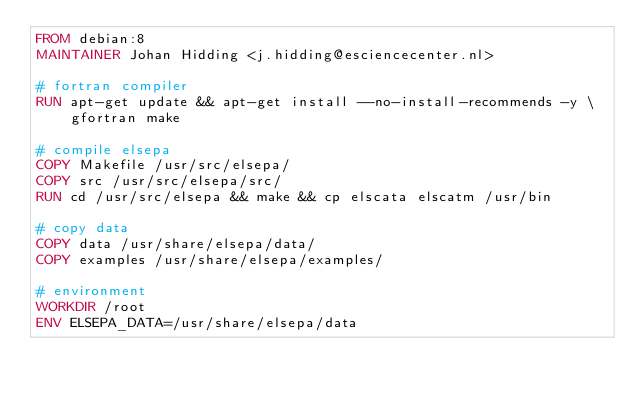Convert code to text. <code><loc_0><loc_0><loc_500><loc_500><_Dockerfile_>FROM debian:8
MAINTAINER Johan Hidding <j.hidding@esciencecenter.nl>

# fortran compiler
RUN apt-get update && apt-get install --no-install-recommends -y \
    gfortran make

# compile elsepa
COPY Makefile /usr/src/elsepa/
COPY src /usr/src/elsepa/src/
RUN cd /usr/src/elsepa && make && cp elscata elscatm /usr/bin

# copy data
COPY data /usr/share/elsepa/data/
COPY examples /usr/share/elsepa/examples/

# environment
WORKDIR /root
ENV ELSEPA_DATA=/usr/share/elsepa/data

</code> 